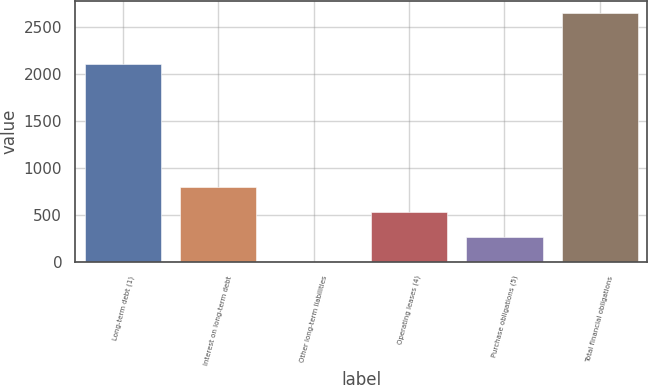<chart> <loc_0><loc_0><loc_500><loc_500><bar_chart><fcel>Long-term debt (1)<fcel>Interest on long-term debt<fcel>Other long-term liabilities<fcel>Operating leases (4)<fcel>Purchase obligations (5)<fcel>Total financial obligations<nl><fcel>2105.4<fcel>793.33<fcel>0.4<fcel>529.02<fcel>264.71<fcel>2643.5<nl></chart> 